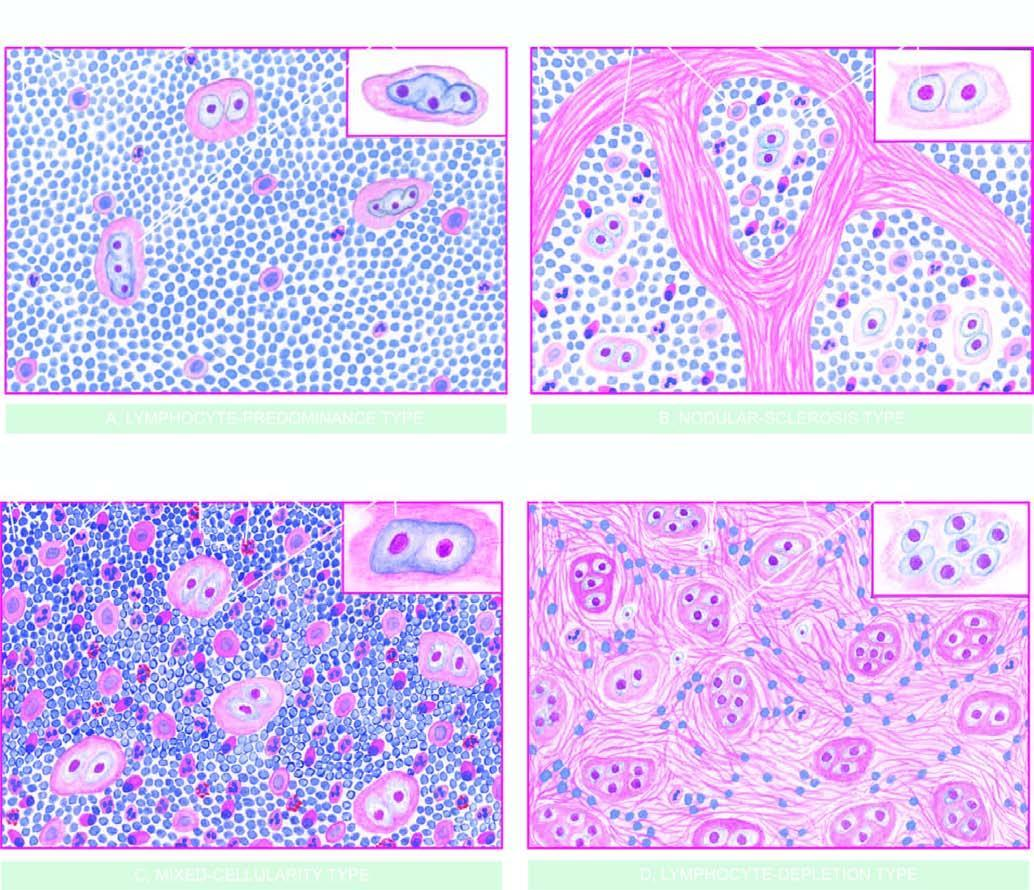what does the inset on right side of each type show?
Answer the question using a single word or phrase. The morphologic variant of rs cell seen more often in particular histologic type 